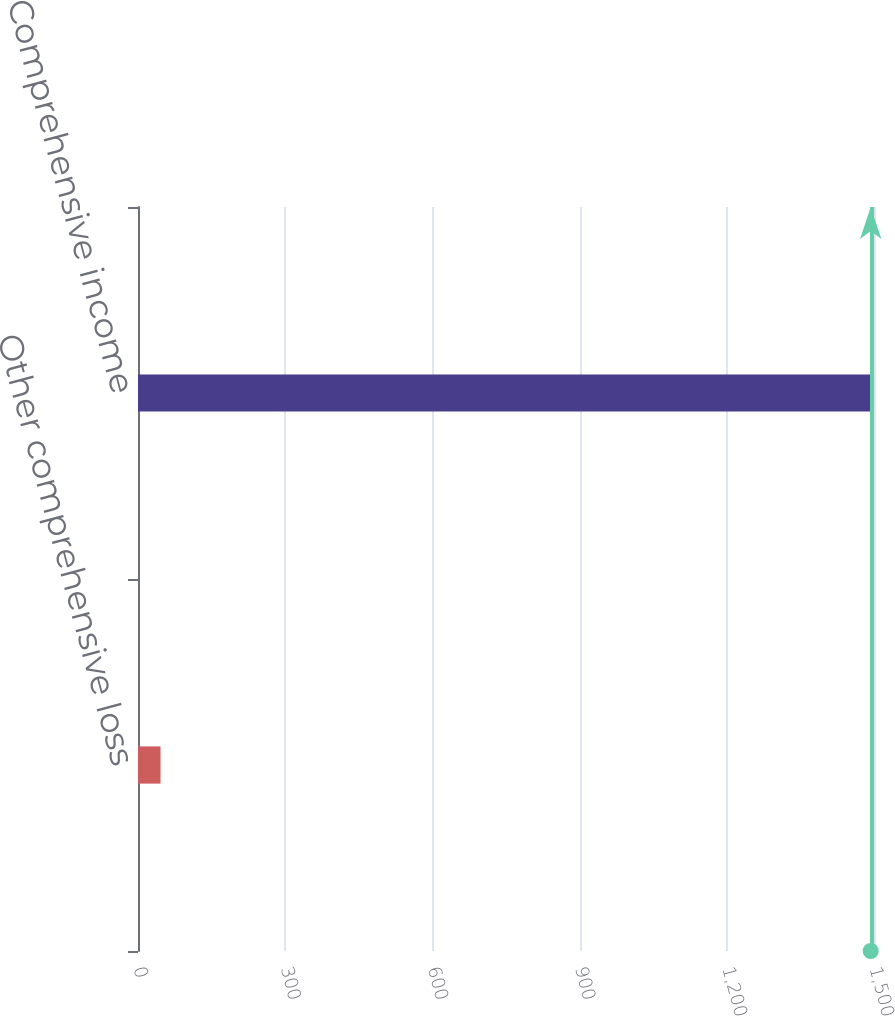Convert chart. <chart><loc_0><loc_0><loc_500><loc_500><bar_chart><fcel>Other comprehensive loss<fcel>Comprehensive income<nl><fcel>45.9<fcel>1493.3<nl></chart> 